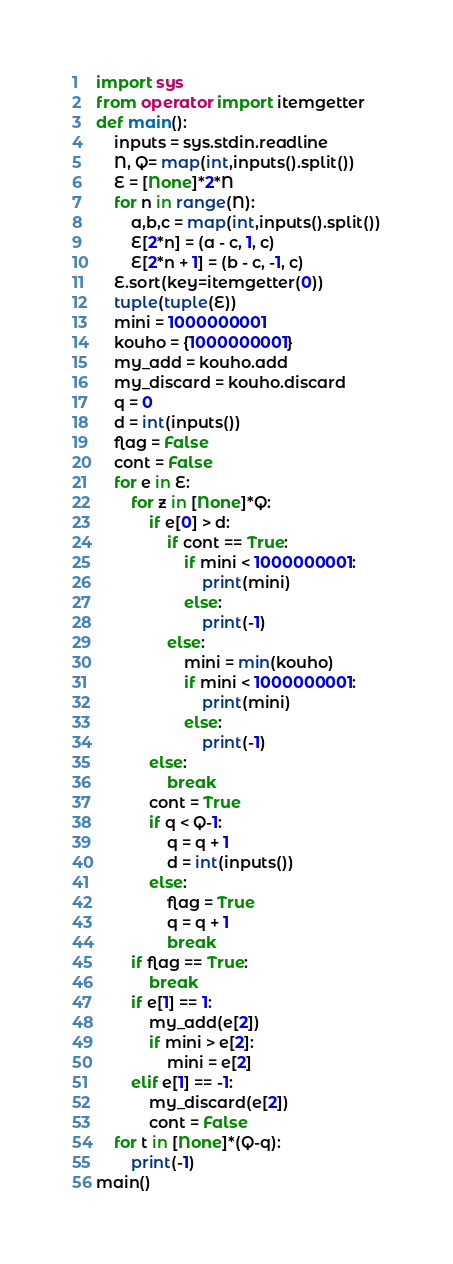<code> <loc_0><loc_0><loc_500><loc_500><_Python_>import sys
from operator import itemgetter
def main():
	inputs = sys.stdin.readline
	N, Q= map(int,inputs().split())
	E = [None]*2*N
	for n in range(N):
		a,b,c = map(int,inputs().split())
		E[2*n] = (a - c, 1, c)
		E[2*n + 1] = (b - c, -1, c)
	E.sort(key=itemgetter(0))
	tuple(tuple(E))
	mini = 1000000001
	kouho = {1000000001}
	my_add = kouho.add
	my_discard = kouho.discard
	q = 0
	d = int(inputs())
	flag = False
	cont = False
	for e in E:
		for z in [None]*Q:
			if e[0] > d:
				if cont == True:
					if mini < 1000000001:
						print(mini)
					else:
						print(-1)
				else:
					mini = min(kouho)
					if mini < 1000000001:
						print(mini)
					else:
						print(-1)
			else:
				break
			cont = True
			if q < Q-1:
				q = q + 1
				d = int(inputs())
			else:
				flag = True
				q = q + 1
				break
		if flag == True:
			break
		if e[1] == 1:
			my_add(e[2])
			if mini > e[2]:
				mini = e[2]
		elif e[1] == -1:
			my_discard(e[2])
			cont = False
	for t in [None]*(Q-q):
		print(-1)
main()</code> 